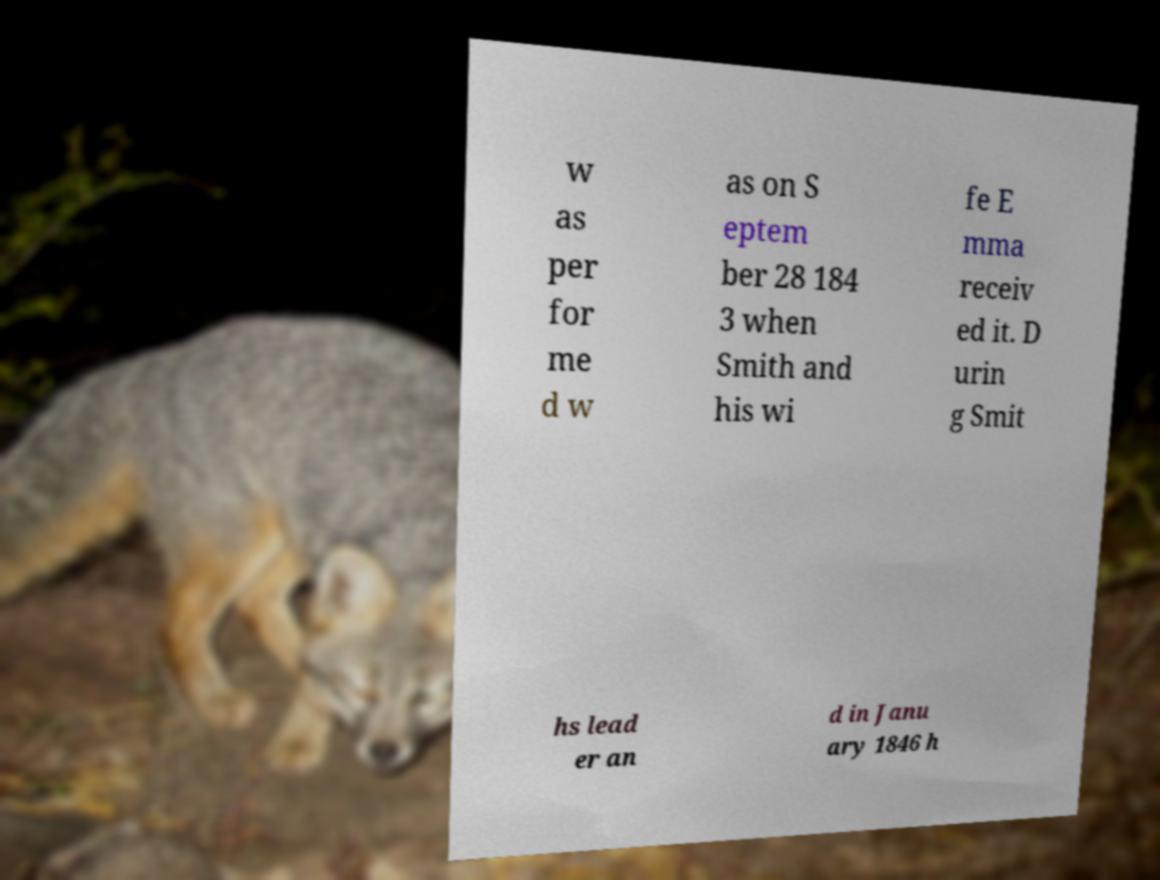Could you extract and type out the text from this image? w as per for me d w as on S eptem ber 28 184 3 when Smith and his wi fe E mma receiv ed it. D urin g Smit hs lead er an d in Janu ary 1846 h 